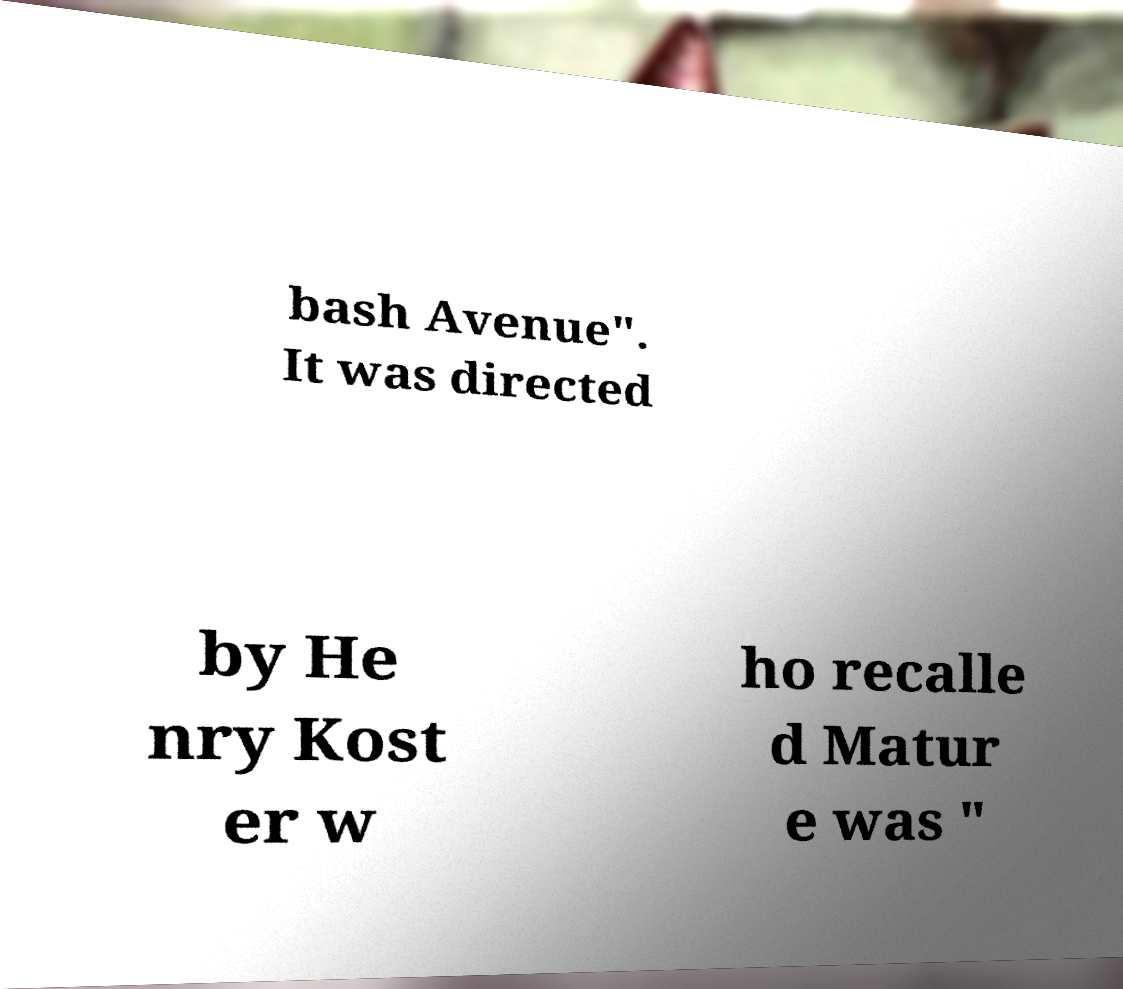There's text embedded in this image that I need extracted. Can you transcribe it verbatim? bash Avenue". It was directed by He nry Kost er w ho recalle d Matur e was " 